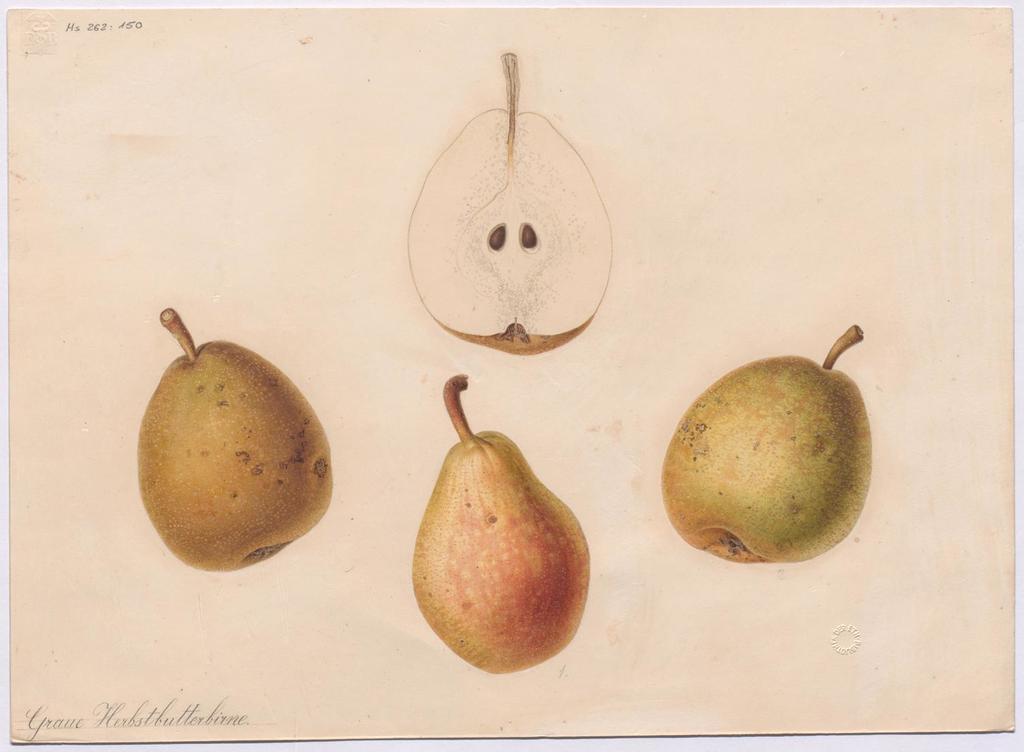What is depicted on the paper in the image? There is a drawing of pears on the paper. What color is the background of the image? The background of the image is white in color. How many pears are shaking in the alley in the image? There are no pears shaking in an alley in the image; the image features a drawing of pears on paper with a white background. 